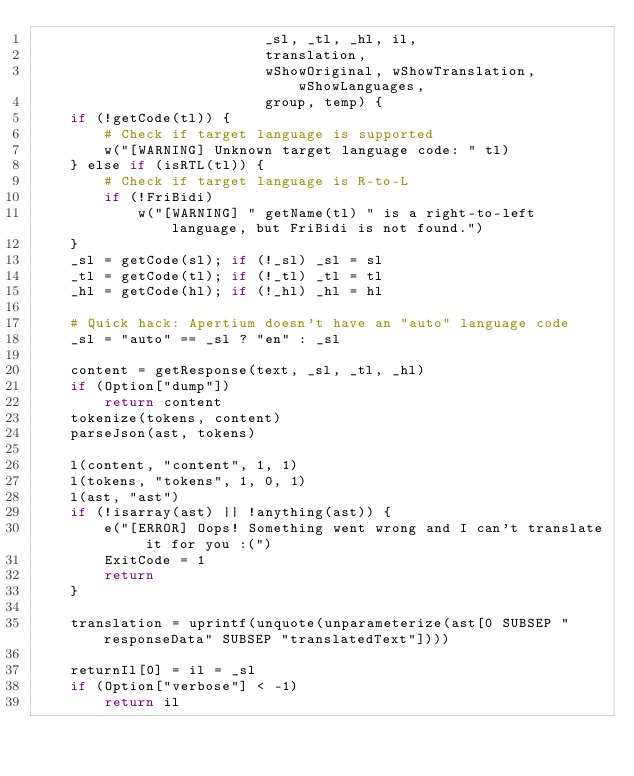Convert code to text. <code><loc_0><loc_0><loc_500><loc_500><_Awk_>                           _sl, _tl, _hl, il,
                           translation,
                           wShowOriginal, wShowTranslation, wShowLanguages,
                           group, temp) {
    if (!getCode(tl)) {
        # Check if target language is supported
        w("[WARNING] Unknown target language code: " tl)
    } else if (isRTL(tl)) {
        # Check if target language is R-to-L
        if (!FriBidi)
            w("[WARNING] " getName(tl) " is a right-to-left language, but FriBidi is not found.")
    }
    _sl = getCode(sl); if (!_sl) _sl = sl
    _tl = getCode(tl); if (!_tl) _tl = tl
    _hl = getCode(hl); if (!_hl) _hl = hl

    # Quick hack: Apertium doesn't have an "auto" language code
    _sl = "auto" == _sl ? "en" : _sl

    content = getResponse(text, _sl, _tl, _hl)
    if (Option["dump"])
        return content
    tokenize(tokens, content)
    parseJson(ast, tokens)

    l(content, "content", 1, 1)
    l(tokens, "tokens", 1, 0, 1)
    l(ast, "ast")
    if (!isarray(ast) || !anything(ast)) {
        e("[ERROR] Oops! Something went wrong and I can't translate it for you :(")
        ExitCode = 1
        return
    }

    translation = uprintf(unquote(unparameterize(ast[0 SUBSEP "responseData" SUBSEP "translatedText"])))

    returnIl[0] = il = _sl
    if (Option["verbose"] < -1)
        return il</code> 